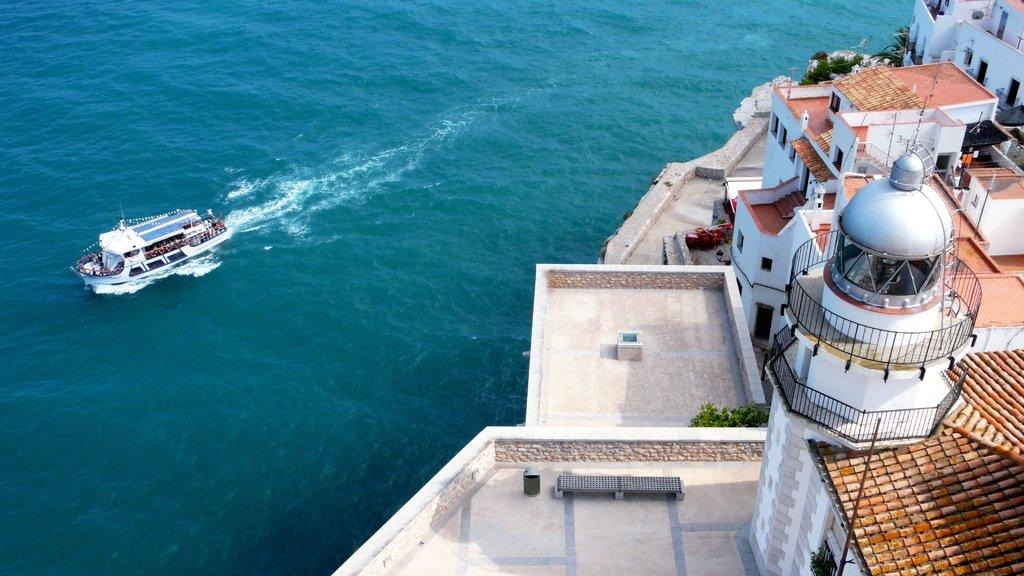What structures are located on the right side of the image? There are buildings with windows, railings, and trees in the image. Can you describe the boat in the image? There is a boat on the water on the left side of the image. What type of steam is coming out of the trees in the image? There is no steam present in the image; it features buildings, trees, and a boat on the water. 